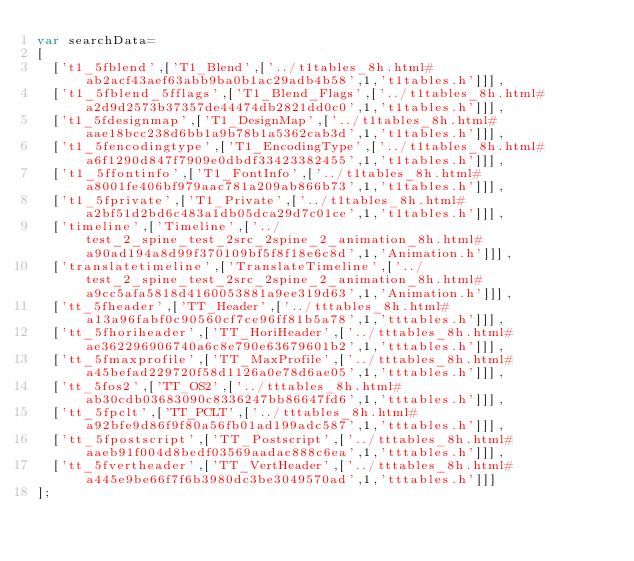<code> <loc_0><loc_0><loc_500><loc_500><_JavaScript_>var searchData=
[
  ['t1_5fblend',['T1_Blend',['../t1tables_8h.html#ab2acf43aef63abb9ba0b1ac29adb4b58',1,'t1tables.h']]],
  ['t1_5fblend_5fflags',['T1_Blend_Flags',['../t1tables_8h.html#a2d9d2573b37357de44474db2821dd0c0',1,'t1tables.h']]],
  ['t1_5fdesignmap',['T1_DesignMap',['../t1tables_8h.html#aae18bcc238d6bb1a9b78b1a5362cab3d',1,'t1tables.h']]],
  ['t1_5fencodingtype',['T1_EncodingType',['../t1tables_8h.html#a6f1290d847f7909e0dbdf33423382455',1,'t1tables.h']]],
  ['t1_5ffontinfo',['T1_FontInfo',['../t1tables_8h.html#a8001fe406bf979aac781a209ab866b73',1,'t1tables.h']]],
  ['t1_5fprivate',['T1_Private',['../t1tables_8h.html#a2bf51d2bd6c483a1db05dca29d7c01ce',1,'t1tables.h']]],
  ['timeline',['Timeline',['../test_2_spine_test_2src_2spine_2_animation_8h.html#a90ad194a8d99f370109bf5f8f18e6c8d',1,'Animation.h']]],
  ['translatetimeline',['TranslateTimeline',['../test_2_spine_test_2src_2spine_2_animation_8h.html#a9cc5afa5818d4160053881a9ee319d63',1,'Animation.h']]],
  ['tt_5fheader',['TT_Header',['../tttables_8h.html#a13a96fabf0c90560cf7ce96ff81b5a78',1,'tttables.h']]],
  ['tt_5fhoriheader',['TT_HoriHeader',['../tttables_8h.html#ae362296906740a6c8e790e63679601b2',1,'tttables.h']]],
  ['tt_5fmaxprofile',['TT_MaxProfile',['../tttables_8h.html#a45befad229720f58d1126a0e78d6ae05',1,'tttables.h']]],
  ['tt_5fos2',['TT_OS2',['../tttables_8h.html#ab30cdb03683090c8336247bb86647fd6',1,'tttables.h']]],
  ['tt_5fpclt',['TT_PCLT',['../tttables_8h.html#a92bfe9d86f9f80a56fb01ad199adc587',1,'tttables.h']]],
  ['tt_5fpostscript',['TT_Postscript',['../tttables_8h.html#aaeb91f004d8bedf03569aadac888c6ea',1,'tttables.h']]],
  ['tt_5fvertheader',['TT_VertHeader',['../tttables_8h.html#a445e9be66f7f6b3980dc3be3049570ad',1,'tttables.h']]]
];
</code> 